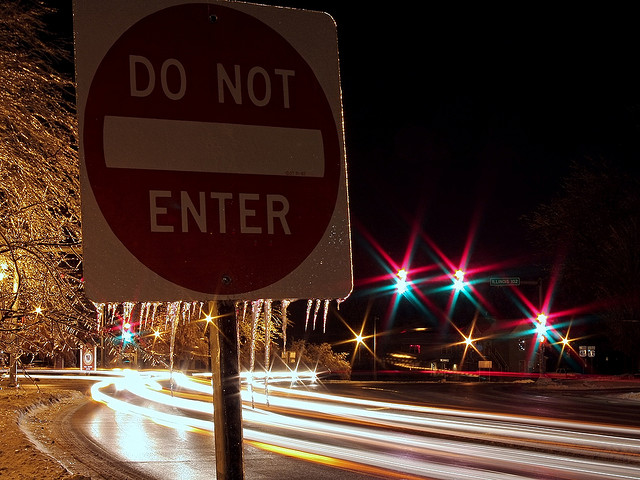Identify the text displayed in this image. DO NOT ENTER 